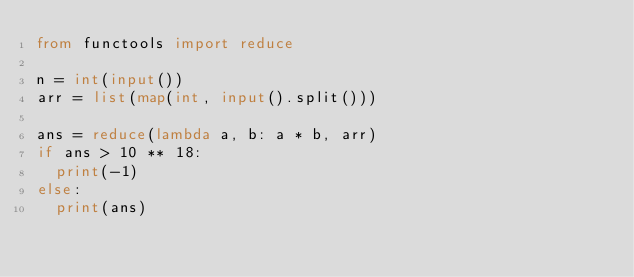Convert code to text. <code><loc_0><loc_0><loc_500><loc_500><_Python_>from functools import reduce

n = int(input())
arr = list(map(int, input().split()))

ans = reduce(lambda a, b: a * b, arr)
if ans > 10 ** 18:
  print(-1)
else:
  print(ans)</code> 